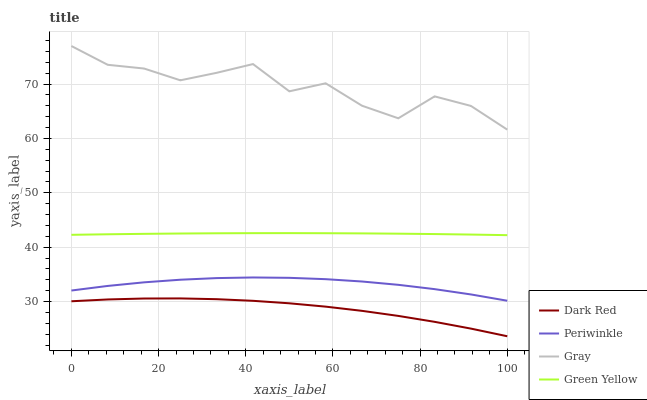Does Dark Red have the minimum area under the curve?
Answer yes or no. Yes. Does Gray have the maximum area under the curve?
Answer yes or no. Yes. Does Green Yellow have the minimum area under the curve?
Answer yes or no. No. Does Green Yellow have the maximum area under the curve?
Answer yes or no. No. Is Green Yellow the smoothest?
Answer yes or no. Yes. Is Gray the roughest?
Answer yes or no. Yes. Is Periwinkle the smoothest?
Answer yes or no. No. Is Periwinkle the roughest?
Answer yes or no. No. Does Dark Red have the lowest value?
Answer yes or no. Yes. Does Green Yellow have the lowest value?
Answer yes or no. No. Does Gray have the highest value?
Answer yes or no. Yes. Does Green Yellow have the highest value?
Answer yes or no. No. Is Dark Red less than Green Yellow?
Answer yes or no. Yes. Is Green Yellow greater than Dark Red?
Answer yes or no. Yes. Does Dark Red intersect Green Yellow?
Answer yes or no. No. 